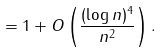Convert formula to latex. <formula><loc_0><loc_0><loc_500><loc_500>= 1 + O \left ( \frac { ( \log n ) ^ { 4 } } { n ^ { 2 } } \right ) .</formula> 